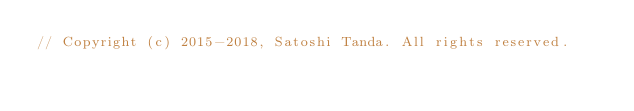Convert code to text. <code><loc_0><loc_0><loc_500><loc_500><_C++_>// Copyright (c) 2015-2018, Satoshi Tanda. All rights reserved.</code> 